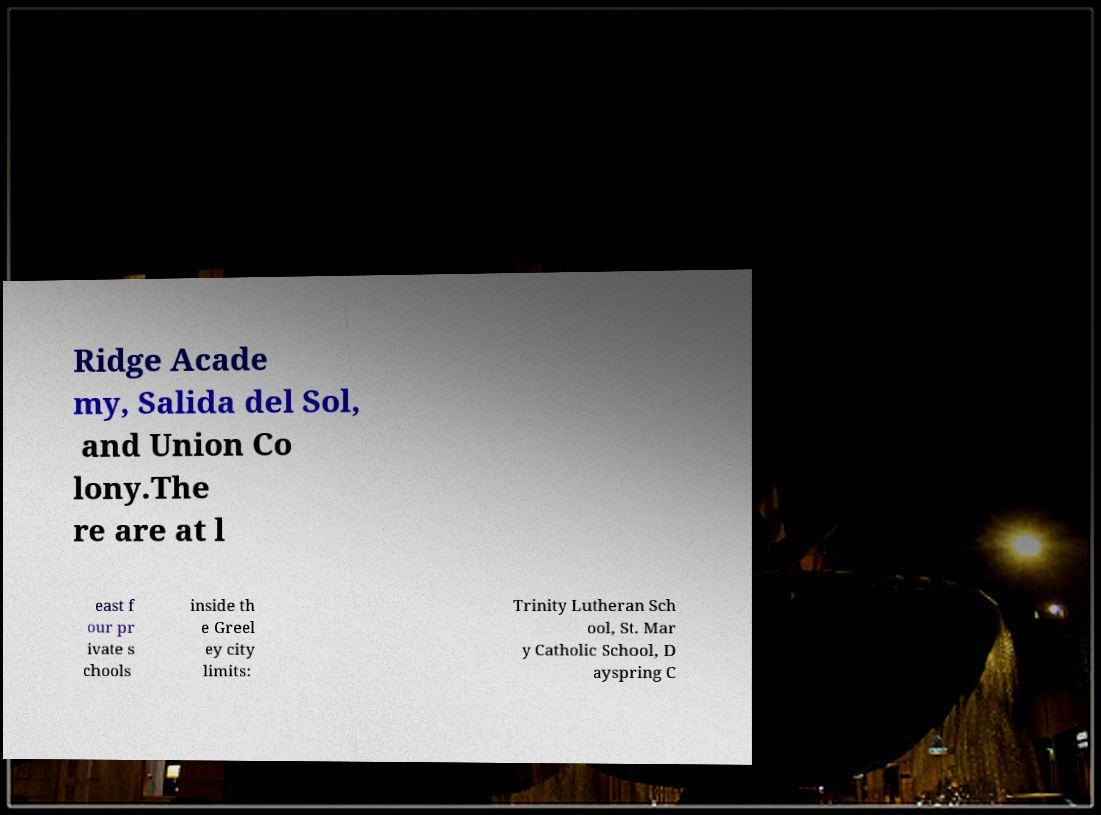There's text embedded in this image that I need extracted. Can you transcribe it verbatim? Ridge Acade my, Salida del Sol, and Union Co lony.The re are at l east f our pr ivate s chools inside th e Greel ey city limits: Trinity Lutheran Sch ool, St. Mar y Catholic School, D ayspring C 